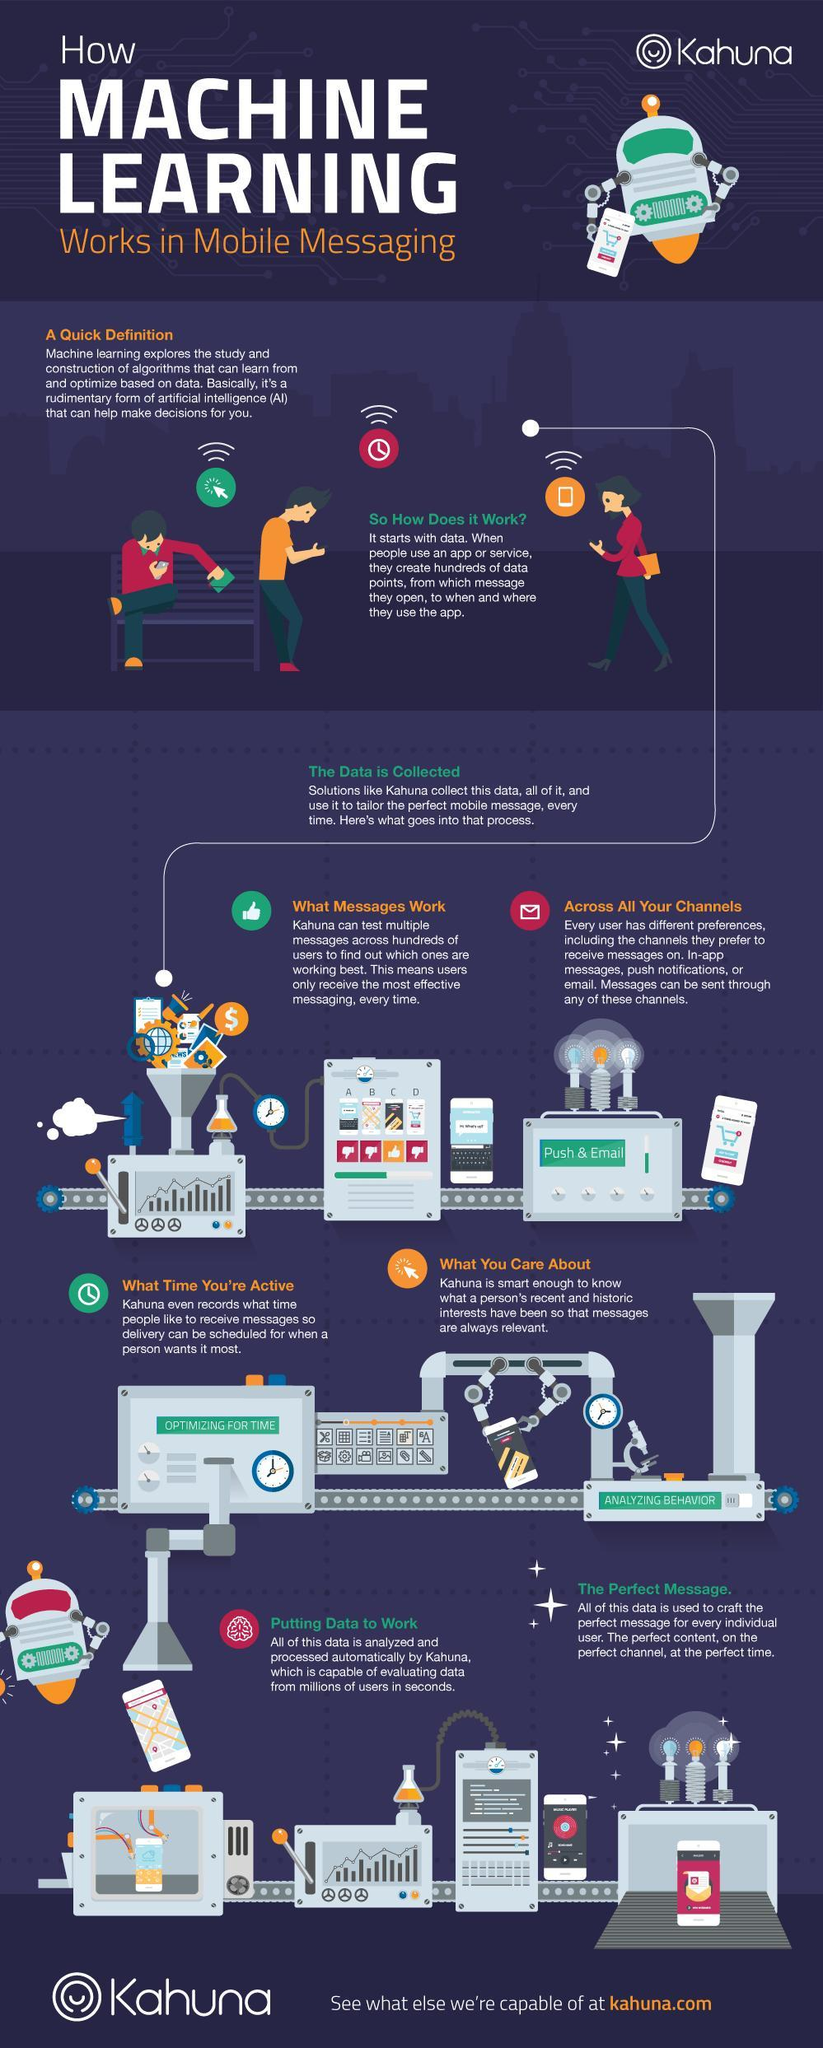How many steps are involved in Kahuna's messaging process?
Answer the question with a short phrase. 6 